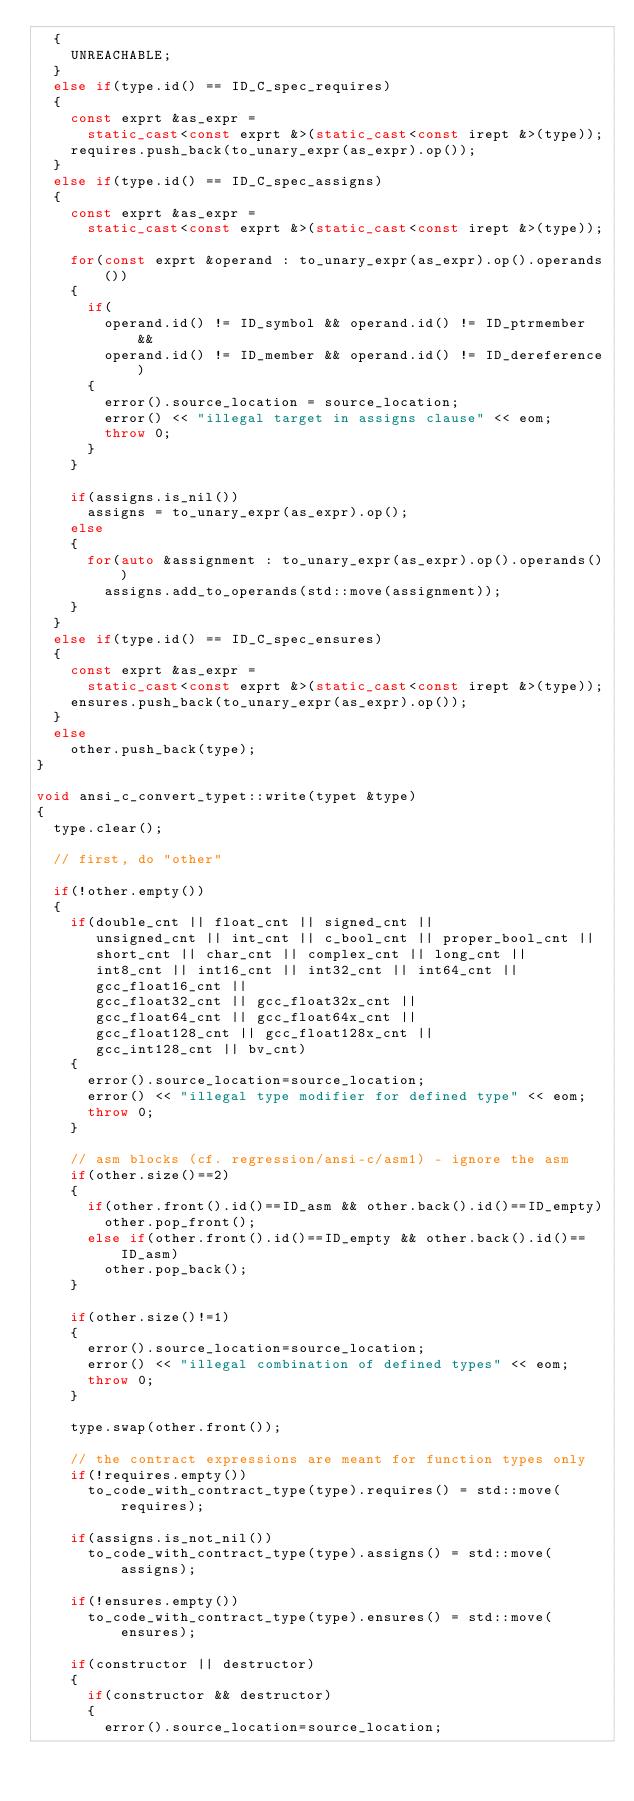Convert code to text. <code><loc_0><loc_0><loc_500><loc_500><_C++_>  {
    UNREACHABLE;
  }
  else if(type.id() == ID_C_spec_requires)
  {
    const exprt &as_expr =
      static_cast<const exprt &>(static_cast<const irept &>(type));
    requires.push_back(to_unary_expr(as_expr).op());
  }
  else if(type.id() == ID_C_spec_assigns)
  {
    const exprt &as_expr =
      static_cast<const exprt &>(static_cast<const irept &>(type));

    for(const exprt &operand : to_unary_expr(as_expr).op().operands())
    {
      if(
        operand.id() != ID_symbol && operand.id() != ID_ptrmember &&
        operand.id() != ID_member && operand.id() != ID_dereference)
      {
        error().source_location = source_location;
        error() << "illegal target in assigns clause" << eom;
        throw 0;
      }
    }

    if(assigns.is_nil())
      assigns = to_unary_expr(as_expr).op();
    else
    {
      for(auto &assignment : to_unary_expr(as_expr).op().operands())
        assigns.add_to_operands(std::move(assignment));
    }
  }
  else if(type.id() == ID_C_spec_ensures)
  {
    const exprt &as_expr =
      static_cast<const exprt &>(static_cast<const irept &>(type));
    ensures.push_back(to_unary_expr(as_expr).op());
  }
  else
    other.push_back(type);
}

void ansi_c_convert_typet::write(typet &type)
{
  type.clear();

  // first, do "other"

  if(!other.empty())
  {
    if(double_cnt || float_cnt || signed_cnt ||
       unsigned_cnt || int_cnt || c_bool_cnt || proper_bool_cnt ||
       short_cnt || char_cnt || complex_cnt || long_cnt ||
       int8_cnt || int16_cnt || int32_cnt || int64_cnt ||
       gcc_float16_cnt ||
       gcc_float32_cnt || gcc_float32x_cnt ||
       gcc_float64_cnt || gcc_float64x_cnt ||
       gcc_float128_cnt || gcc_float128x_cnt ||
       gcc_int128_cnt || bv_cnt)
    {
      error().source_location=source_location;
      error() << "illegal type modifier for defined type" << eom;
      throw 0;
    }

    // asm blocks (cf. regression/ansi-c/asm1) - ignore the asm
    if(other.size()==2)
    {
      if(other.front().id()==ID_asm && other.back().id()==ID_empty)
        other.pop_front();
      else if(other.front().id()==ID_empty && other.back().id()==ID_asm)
        other.pop_back();
    }

    if(other.size()!=1)
    {
      error().source_location=source_location;
      error() << "illegal combination of defined types" << eom;
      throw 0;
    }

    type.swap(other.front());

    // the contract expressions are meant for function types only
    if(!requires.empty())
      to_code_with_contract_type(type).requires() = std::move(requires);

    if(assigns.is_not_nil())
      to_code_with_contract_type(type).assigns() = std::move(assigns);

    if(!ensures.empty())
      to_code_with_contract_type(type).ensures() = std::move(ensures);

    if(constructor || destructor)
    {
      if(constructor && destructor)
      {
        error().source_location=source_location;</code> 